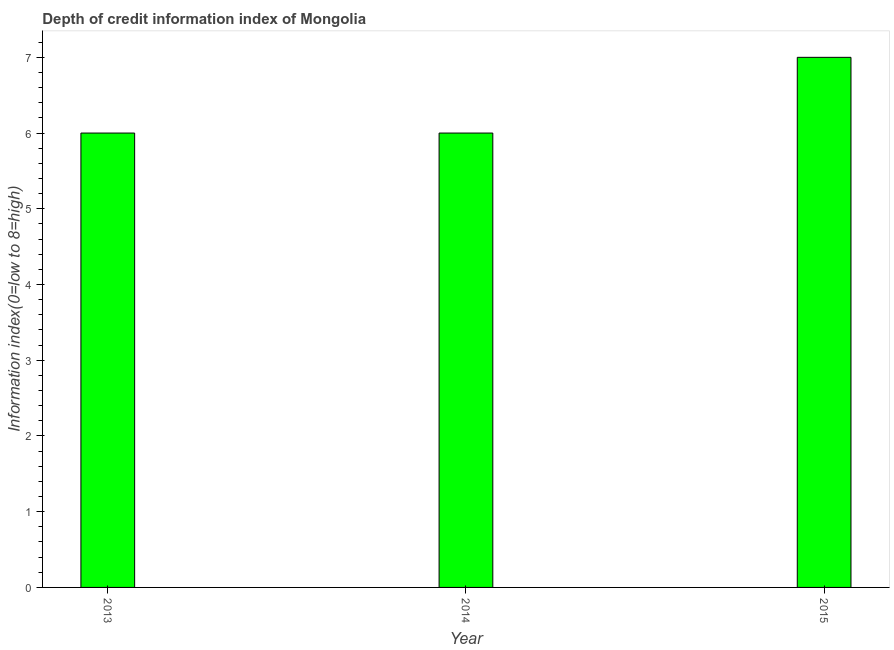Does the graph contain grids?
Offer a terse response. No. What is the title of the graph?
Make the answer very short. Depth of credit information index of Mongolia. What is the label or title of the X-axis?
Ensure brevity in your answer.  Year. What is the label or title of the Y-axis?
Give a very brief answer. Information index(0=low to 8=high). Across all years, what is the minimum depth of credit information index?
Offer a terse response. 6. In which year was the depth of credit information index maximum?
Offer a terse response. 2015. Do a majority of the years between 2015 and 2013 (inclusive) have depth of credit information index greater than 3.2 ?
Give a very brief answer. Yes. Is the difference between the depth of credit information index in 2014 and 2015 greater than the difference between any two years?
Offer a very short reply. Yes. What is the difference between the highest and the second highest depth of credit information index?
Offer a terse response. 1. Is the sum of the depth of credit information index in 2013 and 2014 greater than the maximum depth of credit information index across all years?
Ensure brevity in your answer.  Yes. In how many years, is the depth of credit information index greater than the average depth of credit information index taken over all years?
Provide a short and direct response. 1. How many bars are there?
Make the answer very short. 3. Are all the bars in the graph horizontal?
Offer a terse response. No. What is the difference between two consecutive major ticks on the Y-axis?
Your answer should be compact. 1. What is the Information index(0=low to 8=high) in 2013?
Keep it short and to the point. 6. What is the Information index(0=low to 8=high) in 2014?
Provide a short and direct response. 6. What is the difference between the Information index(0=low to 8=high) in 2013 and 2014?
Make the answer very short. 0. What is the difference between the Information index(0=low to 8=high) in 2013 and 2015?
Your answer should be very brief. -1. What is the difference between the Information index(0=low to 8=high) in 2014 and 2015?
Your answer should be compact. -1. What is the ratio of the Information index(0=low to 8=high) in 2013 to that in 2015?
Your answer should be compact. 0.86. What is the ratio of the Information index(0=low to 8=high) in 2014 to that in 2015?
Keep it short and to the point. 0.86. 